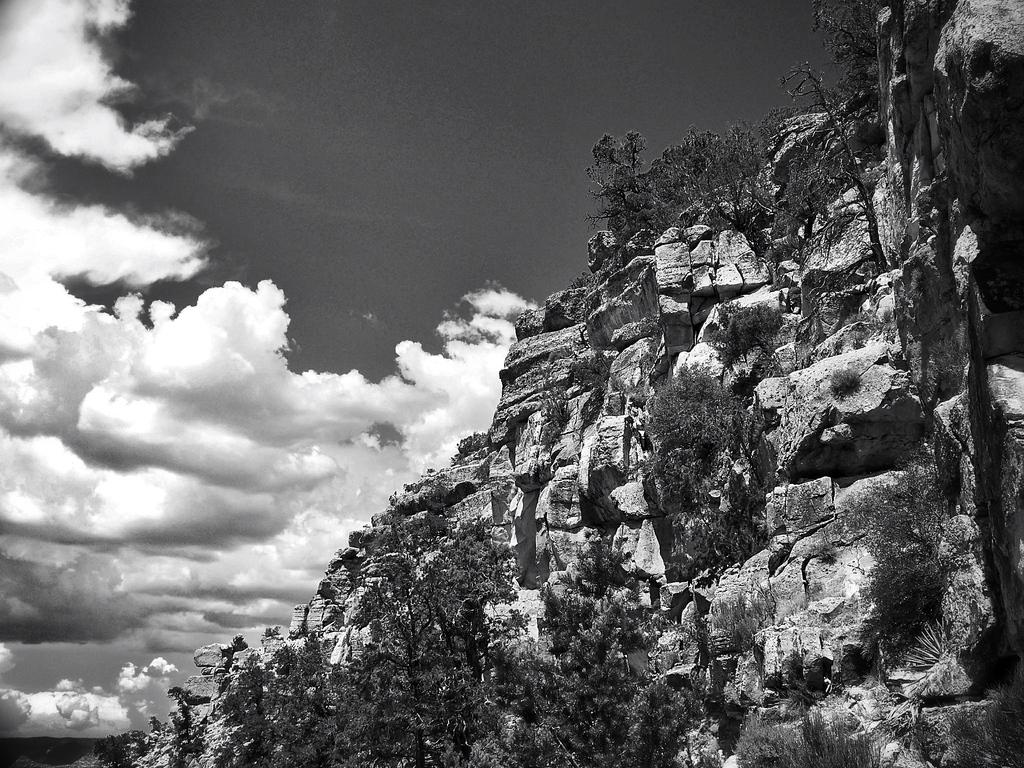What type of natural formation is present in the image? There is a mountain in the image. What other natural elements can be seen in the image? There are plants and trees in the image. What is visible in the background of the image? The sky is visible in the image. How would you describe the sky in the image? The sky appears cloudy in the image. What type of pot is being used by the society in the image? There is no pot or society present in the image; it features a mountain, plants, trees, and a cloudy sky. 